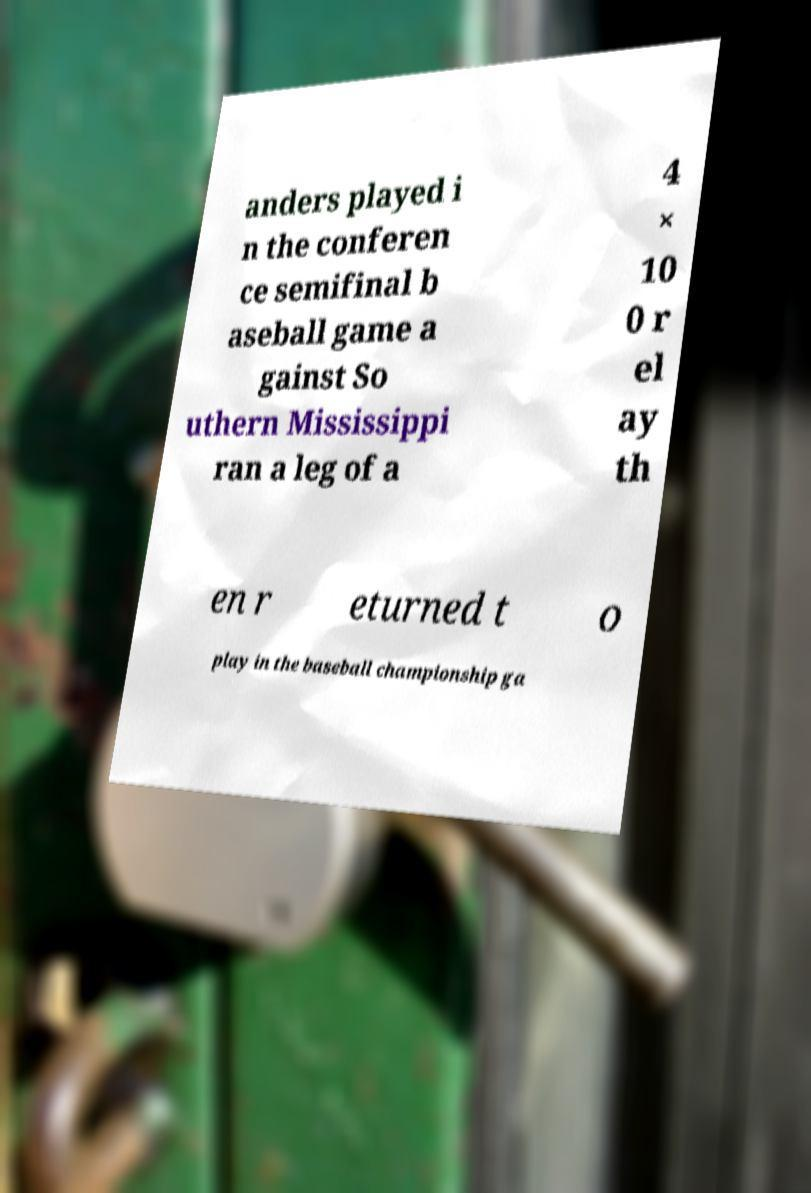Could you assist in decoding the text presented in this image and type it out clearly? anders played i n the conferen ce semifinal b aseball game a gainst So uthern Mississippi ran a leg of a 4 × 10 0 r el ay th en r eturned t o play in the baseball championship ga 